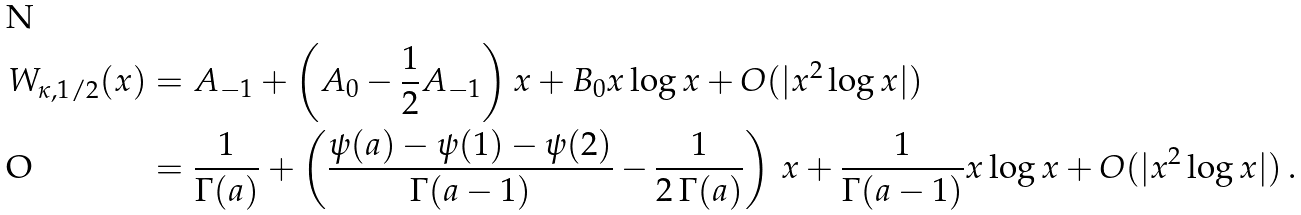Convert formula to latex. <formula><loc_0><loc_0><loc_500><loc_500>W _ { \kappa , 1 / 2 } ( x ) & = A _ { - 1 } + \left ( A _ { 0 } - \frac { 1 } { 2 } A _ { - 1 } \right ) x + B _ { 0 } x \log x + O ( | x ^ { 2 } \log x | ) \\ & = \frac { 1 } { \Gamma ( a ) } + \left ( \frac { \psi ( a ) - \psi ( 1 ) - \psi ( 2 ) } { \Gamma ( a - 1 ) } - \frac { 1 } { 2 \, \Gamma ( a ) } \right ) \, x + \frac { 1 } { \Gamma ( a - 1 ) } x \log x + O ( | x ^ { 2 } \log x | ) \, .</formula> 